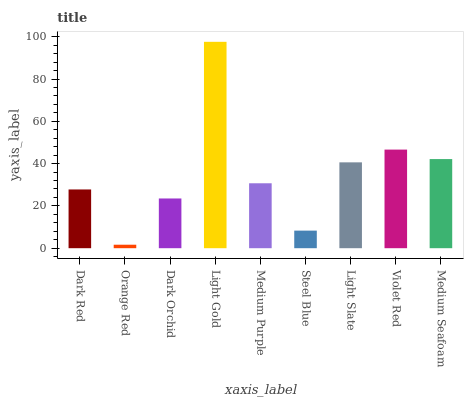Is Orange Red the minimum?
Answer yes or no. Yes. Is Light Gold the maximum?
Answer yes or no. Yes. Is Dark Orchid the minimum?
Answer yes or no. No. Is Dark Orchid the maximum?
Answer yes or no. No. Is Dark Orchid greater than Orange Red?
Answer yes or no. Yes. Is Orange Red less than Dark Orchid?
Answer yes or no. Yes. Is Orange Red greater than Dark Orchid?
Answer yes or no. No. Is Dark Orchid less than Orange Red?
Answer yes or no. No. Is Medium Purple the high median?
Answer yes or no. Yes. Is Medium Purple the low median?
Answer yes or no. Yes. Is Orange Red the high median?
Answer yes or no. No. Is Dark Orchid the low median?
Answer yes or no. No. 